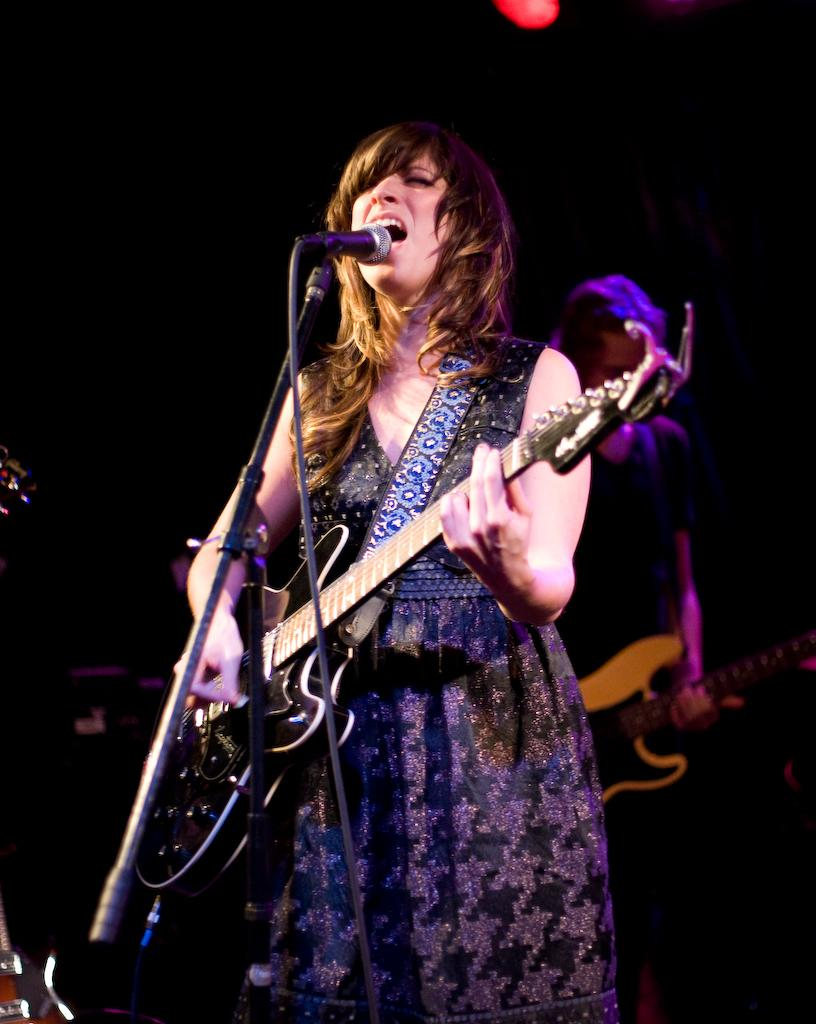What is the woman in the image holding? The woman is holding a guitar. What object is in front of the woman? There is a microphone in front of the woman. Can you describe the other person in the image? The other person in the background of the image is holding a guitar. What type of cherry is the woman using to play the guitar in the image? There is no cherry present in the image, and the woman is using her hands to play the guitar. 